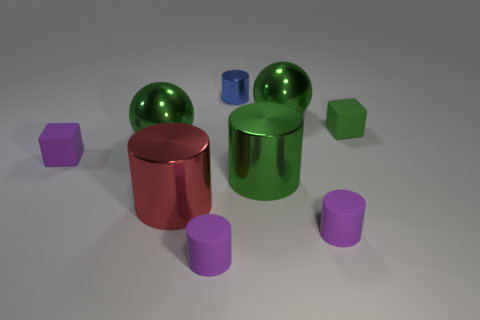Are there any cylinders made of the same material as the tiny green block?
Give a very brief answer. Yes. The tiny cylinder that is left of the small blue metal thing is what color?
Make the answer very short. Purple. There is a green matte thing; does it have the same shape as the big green object that is behind the green matte block?
Offer a very short reply. No. Is there another tiny metallic thing that has the same color as the small shiny thing?
Provide a short and direct response. No. There is a blue cylinder that is the same material as the red object; what is its size?
Ensure brevity in your answer.  Small. There is a tiny purple object behind the green cylinder; is its shape the same as the tiny blue shiny object?
Your answer should be compact. No. How many blue shiny objects are the same size as the green rubber object?
Your answer should be very brief. 1. Are there any cylinders right of the small purple matte cylinder on the right side of the blue metallic object?
Offer a terse response. No. How many things are either large objects that are to the right of the red cylinder or purple metal blocks?
Offer a very short reply. 2. What number of purple rubber cylinders are there?
Provide a short and direct response. 2. 